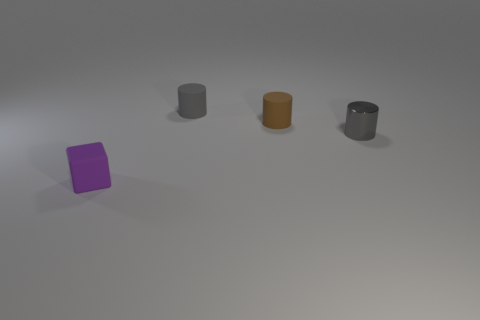Add 3 brown objects. How many objects exist? 7 Subtract all cylinders. How many objects are left? 1 Add 4 brown things. How many brown things are left? 5 Add 3 red shiny balls. How many red shiny balls exist? 3 Subtract 1 brown cylinders. How many objects are left? 3 Subtract all gray spheres. Subtract all rubber cylinders. How many objects are left? 2 